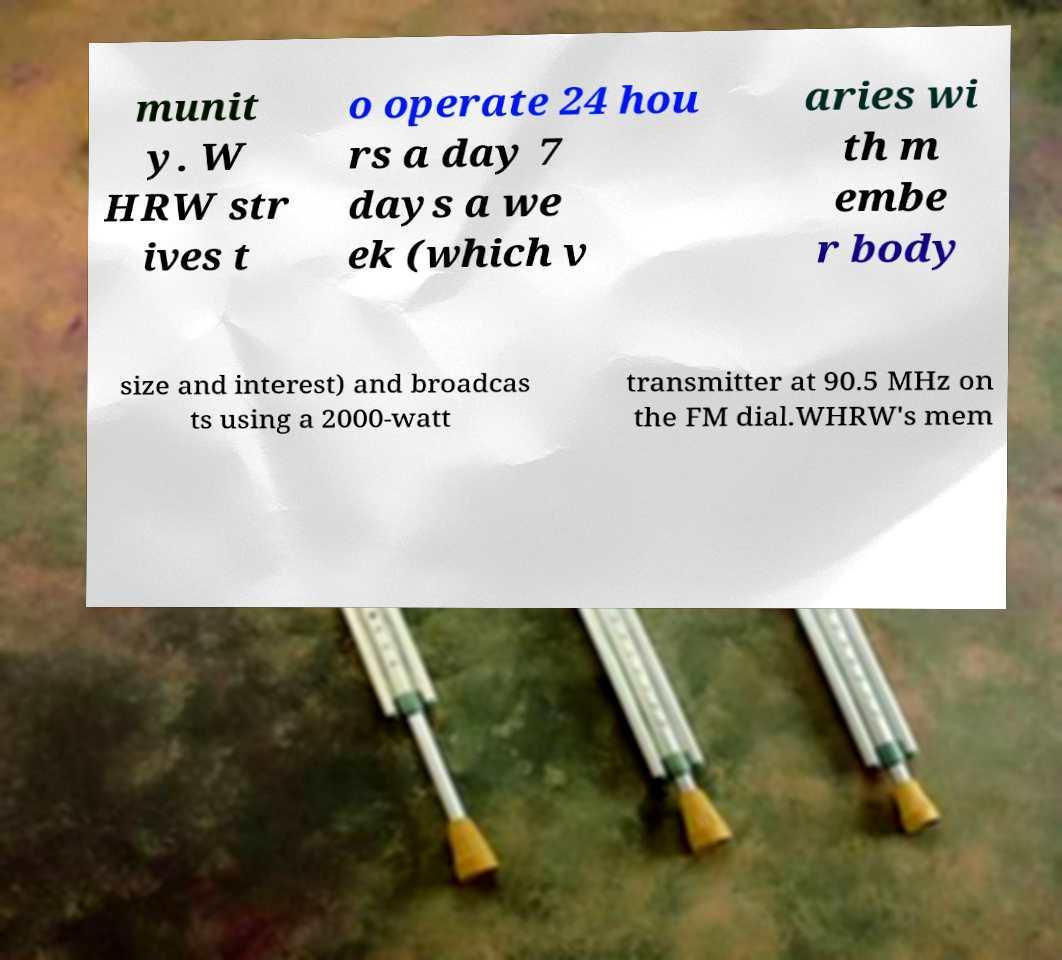What messages or text are displayed in this image? I need them in a readable, typed format. munit y. W HRW str ives t o operate 24 hou rs a day 7 days a we ek (which v aries wi th m embe r body size and interest) and broadcas ts using a 2000-watt transmitter at 90.5 MHz on the FM dial.WHRW's mem 